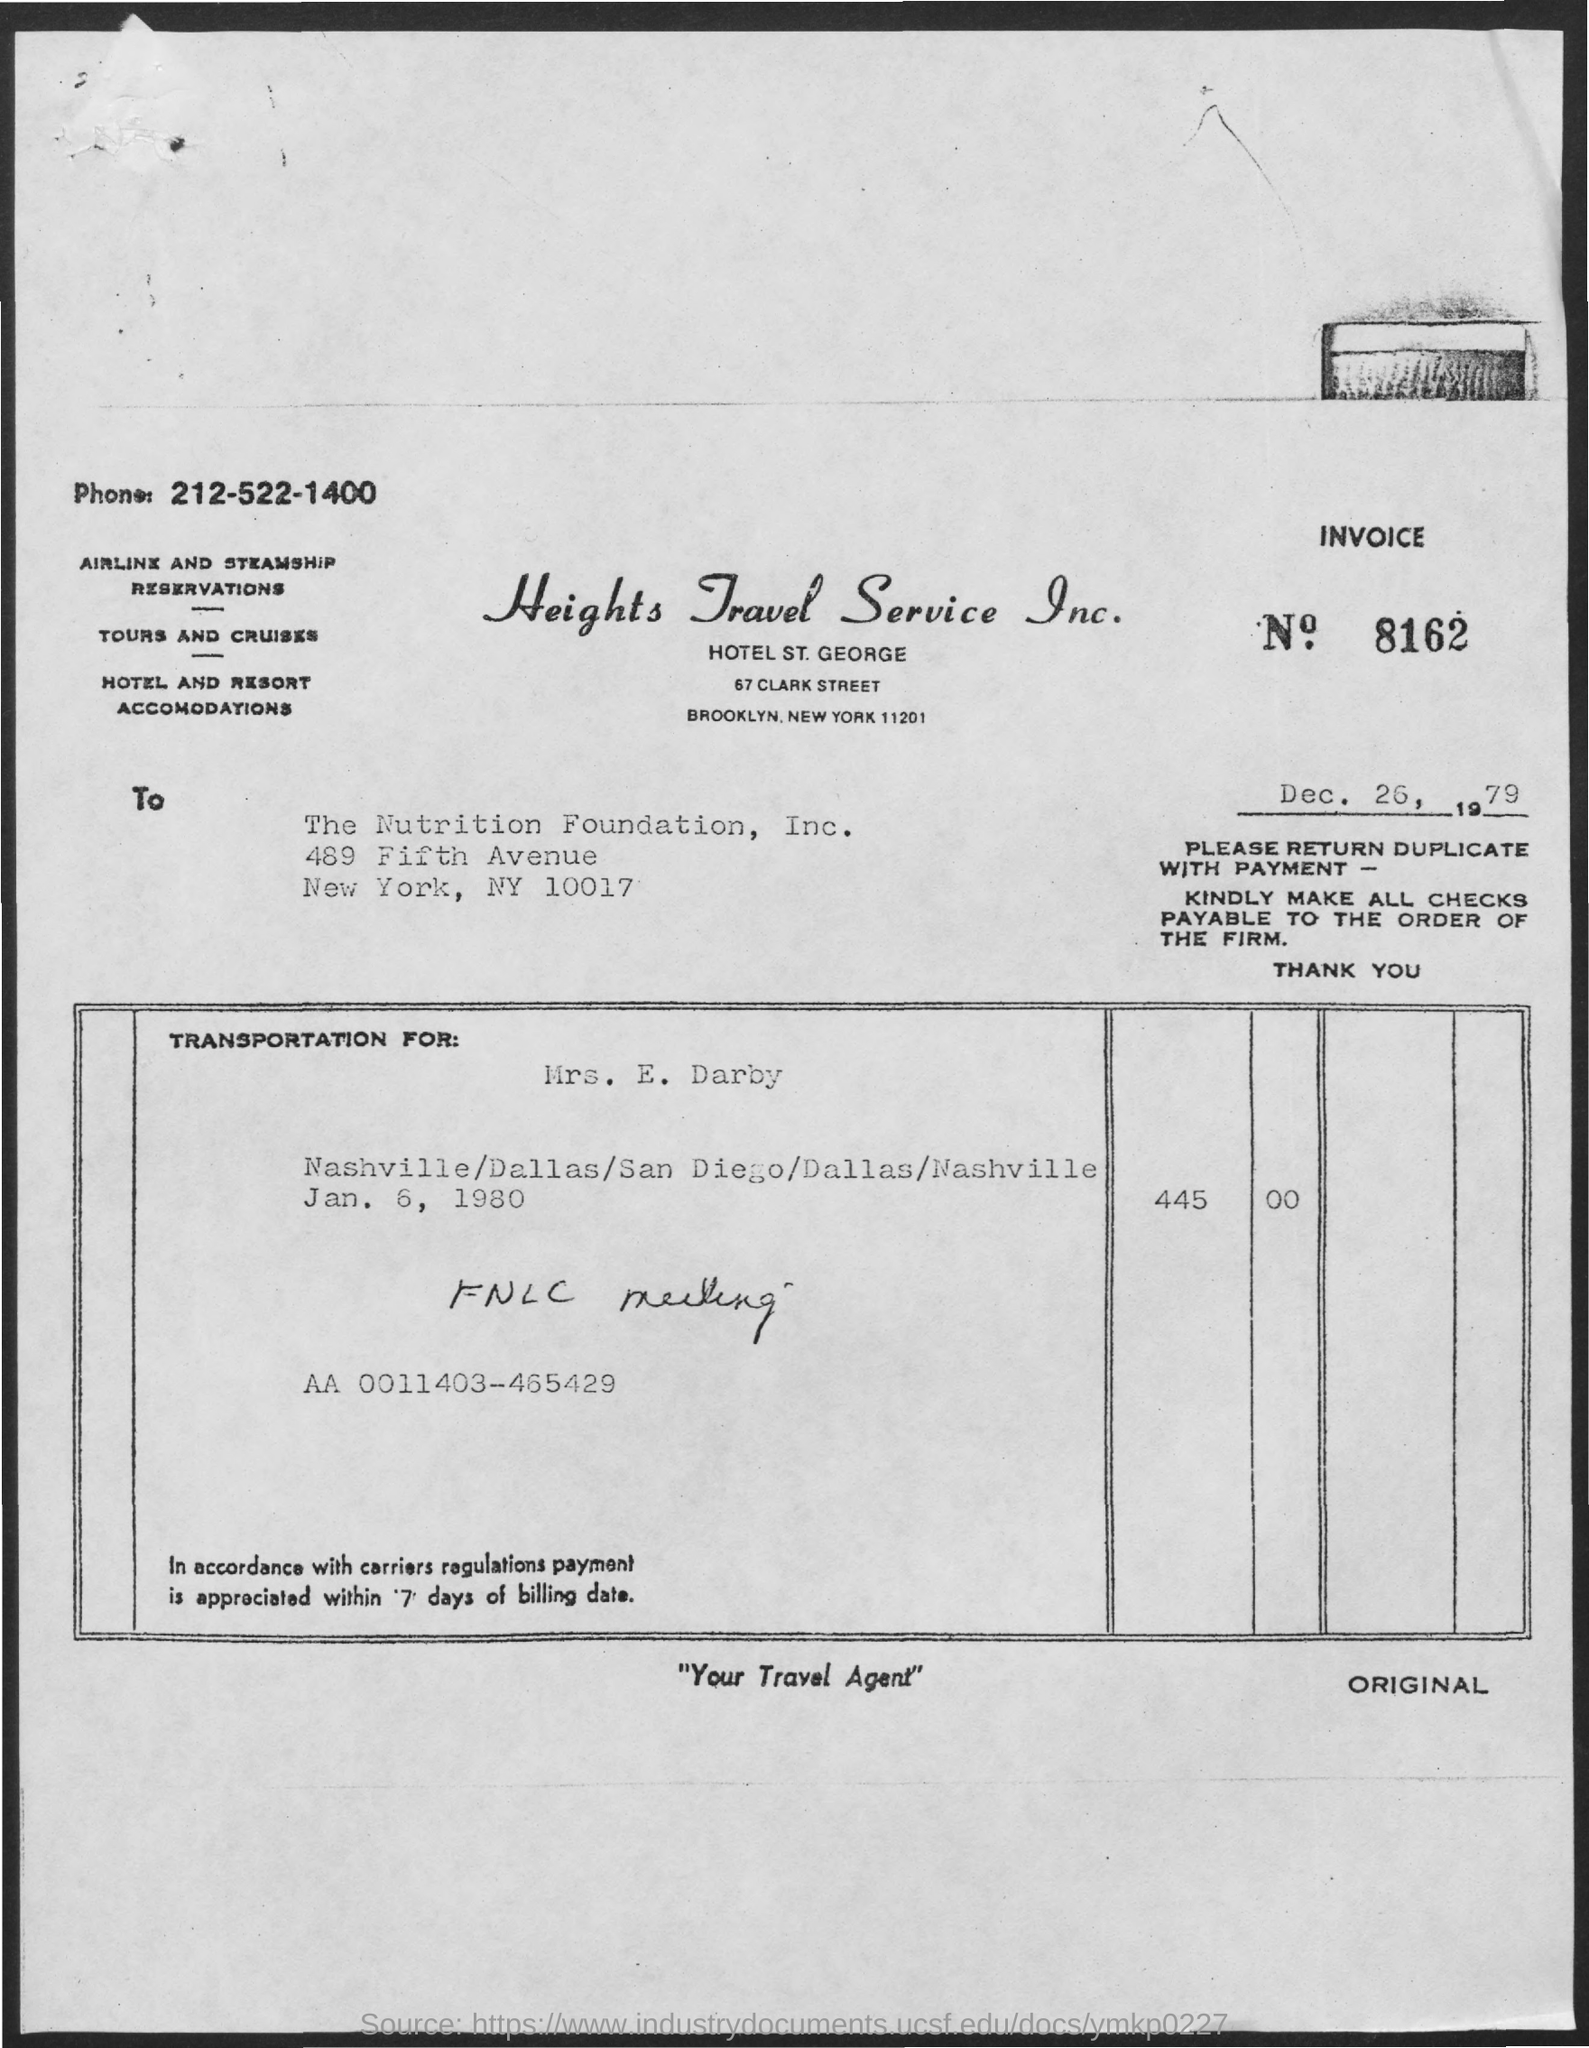What is the Invoice No mentioned in this document?
Keep it short and to the point. 8162. What is the phone no mentioned in this document?
Offer a very short reply. 212-522-1400. To whom, the invoice is addressed?
Offer a terse response. The Nutrition Foundation, Inc. What is the issued date of the invoice?
Give a very brief answer. Dec. 26, 1979. 